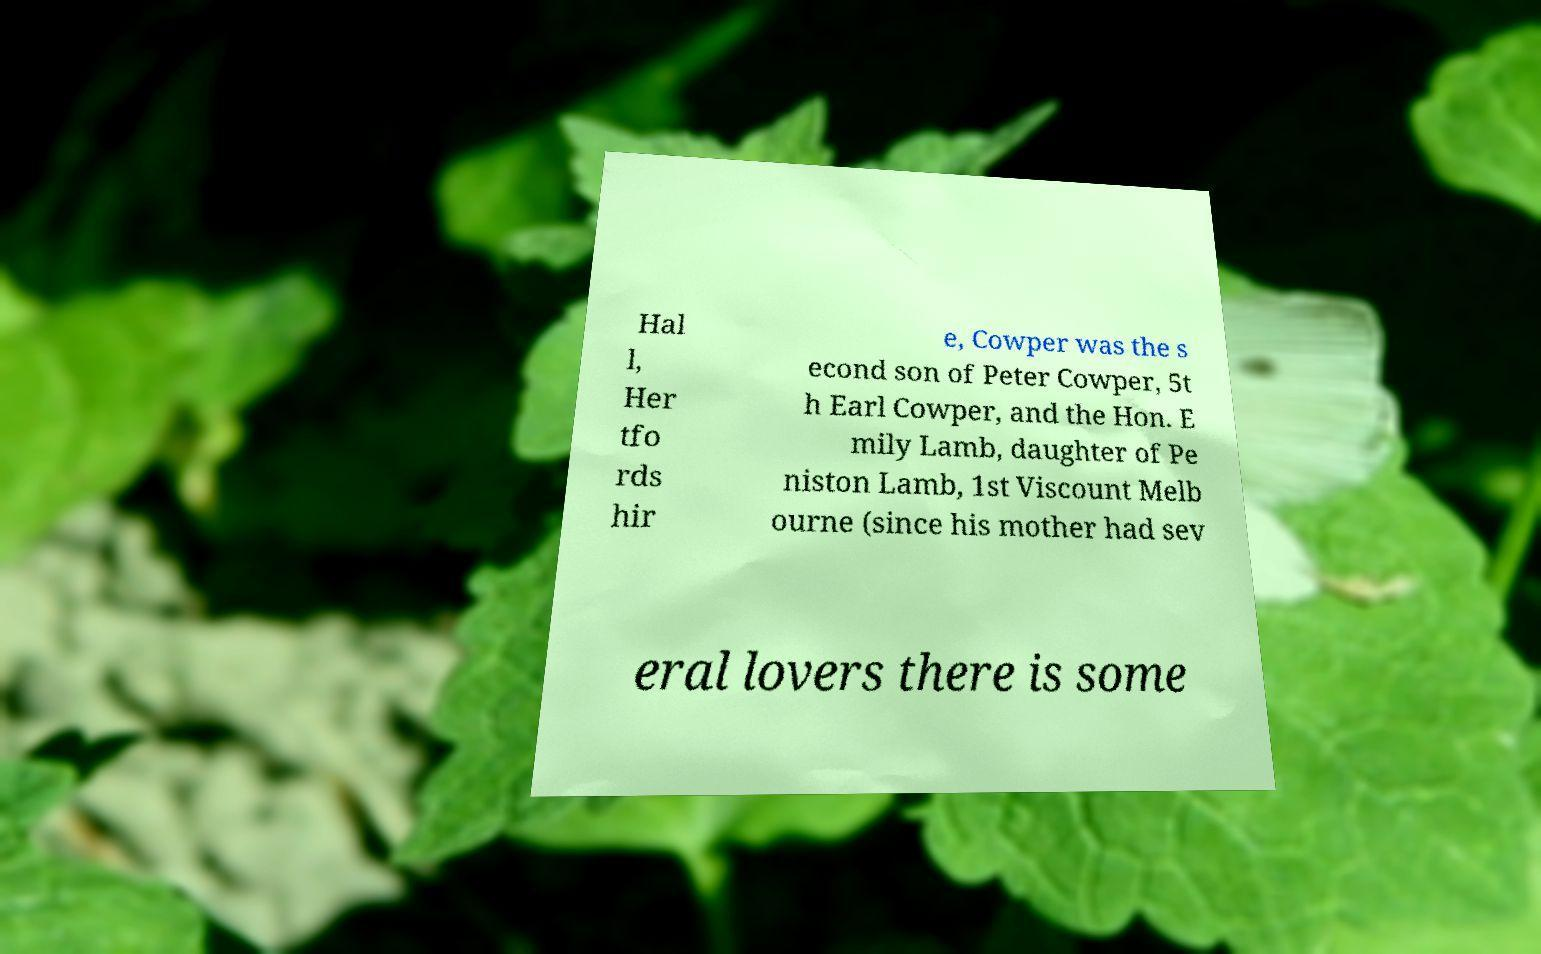Could you extract and type out the text from this image? Hal l, Her tfo rds hir e, Cowper was the s econd son of Peter Cowper, 5t h Earl Cowper, and the Hon. E mily Lamb, daughter of Pe niston Lamb, 1st Viscount Melb ourne (since his mother had sev eral lovers there is some 